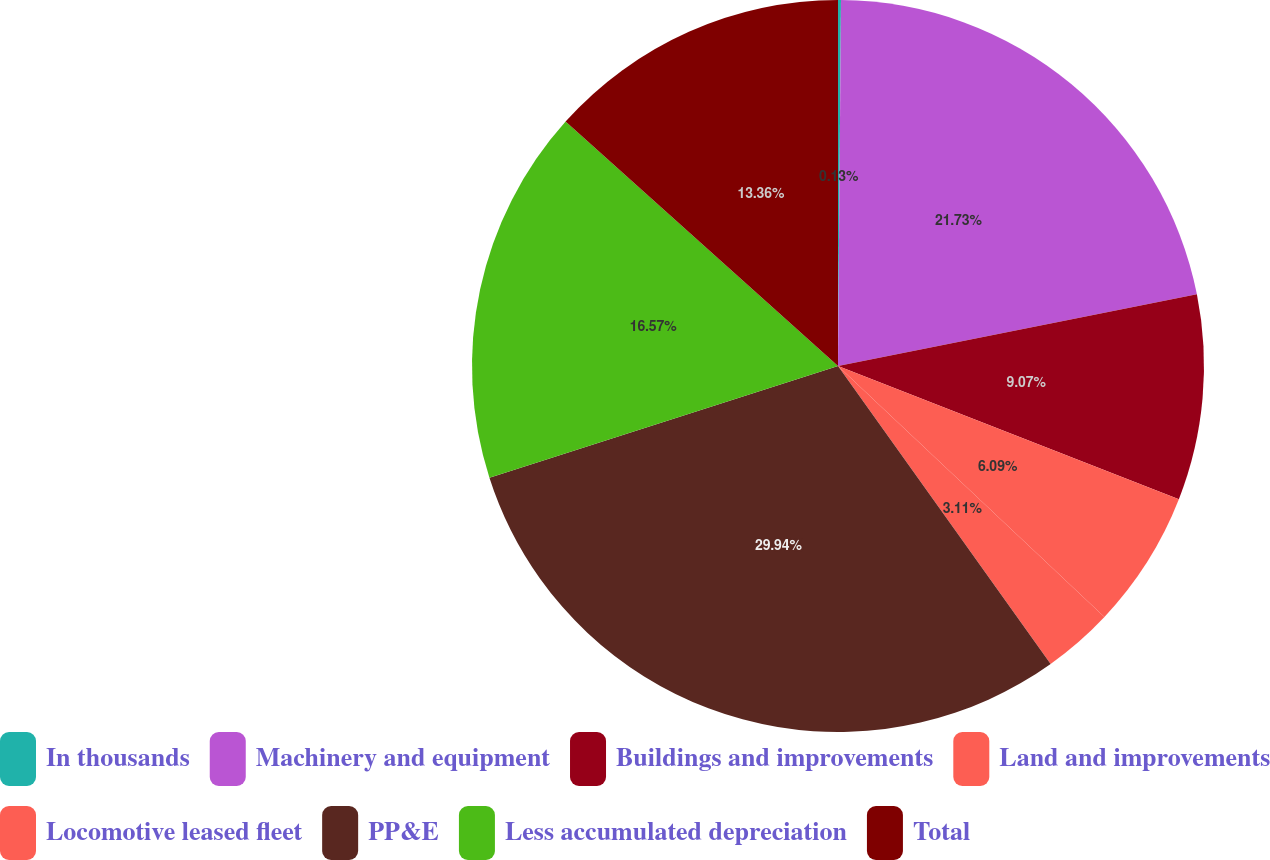Convert chart. <chart><loc_0><loc_0><loc_500><loc_500><pie_chart><fcel>In thousands<fcel>Machinery and equipment<fcel>Buildings and improvements<fcel>Land and improvements<fcel>Locomotive leased fleet<fcel>PP&E<fcel>Less accumulated depreciation<fcel>Total<nl><fcel>0.13%<fcel>21.73%<fcel>9.07%<fcel>6.09%<fcel>3.11%<fcel>29.93%<fcel>16.57%<fcel>13.36%<nl></chart> 